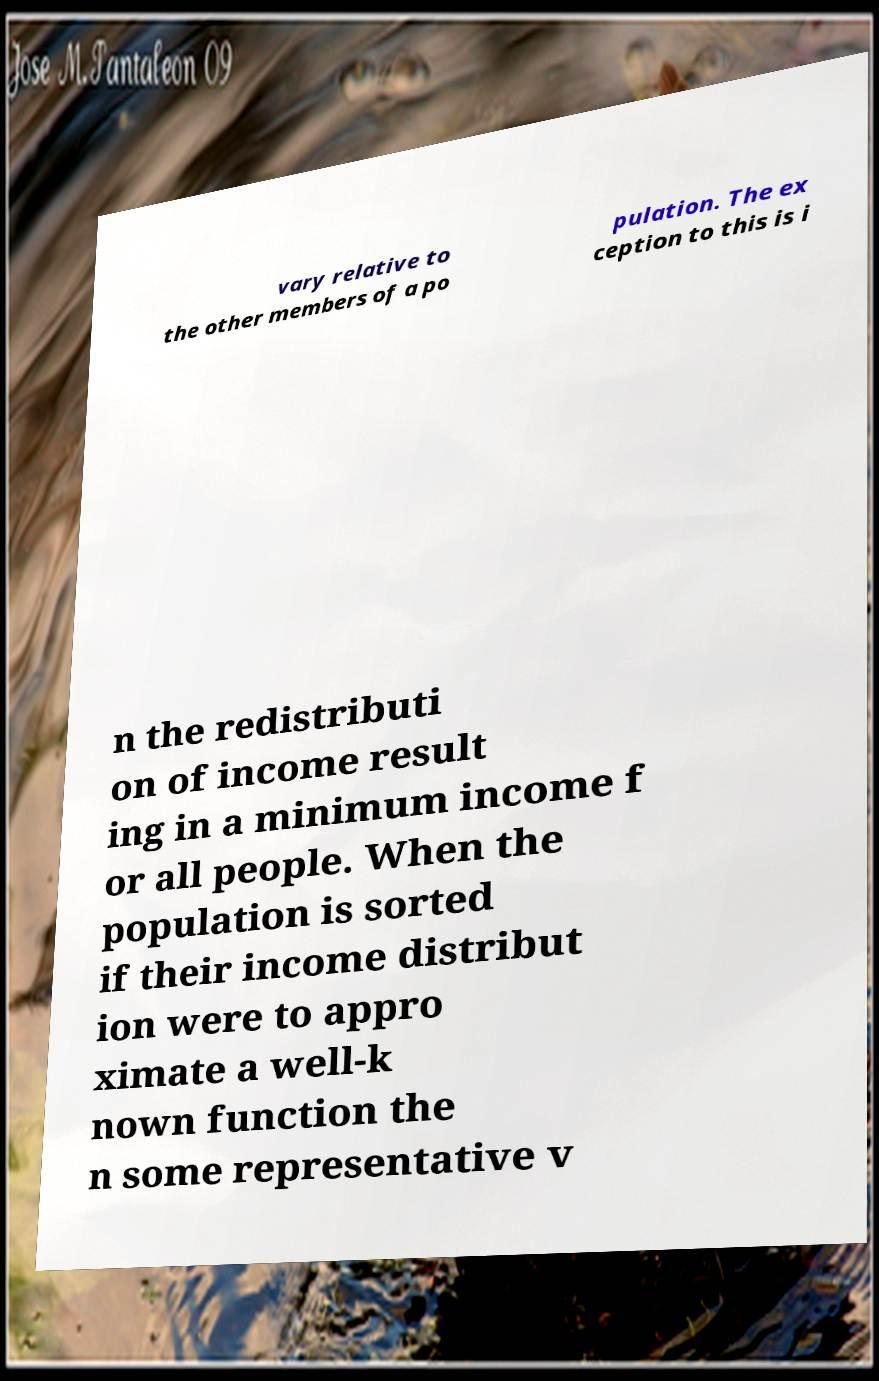Can you accurately transcribe the text from the provided image for me? vary relative to the other members of a po pulation. The ex ception to this is i n the redistributi on of income result ing in a minimum income f or all people. When the population is sorted if their income distribut ion were to appro ximate a well-k nown function the n some representative v 